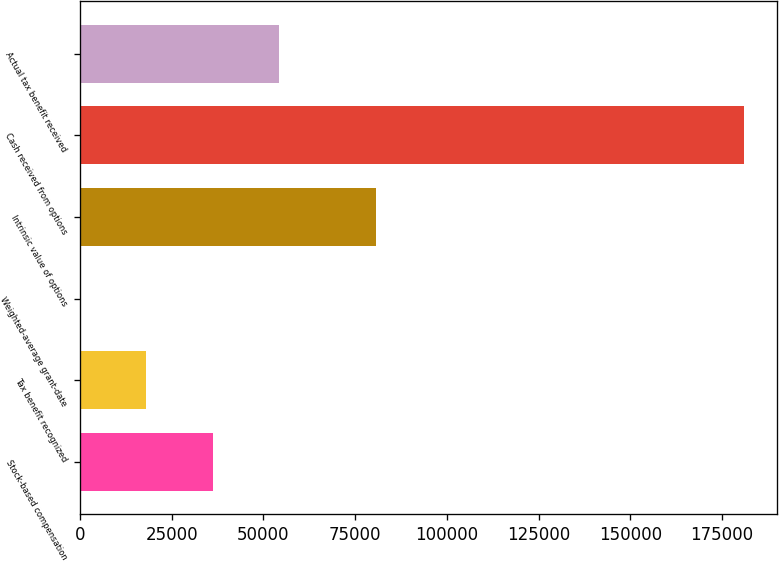<chart> <loc_0><loc_0><loc_500><loc_500><bar_chart><fcel>Stock-based compensation<fcel>Tax benefit recognized<fcel>Weighted-average grant-date<fcel>Intrinsic value of options<fcel>Cash received from options<fcel>Actual tax benefit received<nl><fcel>36217<fcel>18116.3<fcel>15.7<fcel>80781<fcel>181022<fcel>54317.6<nl></chart> 